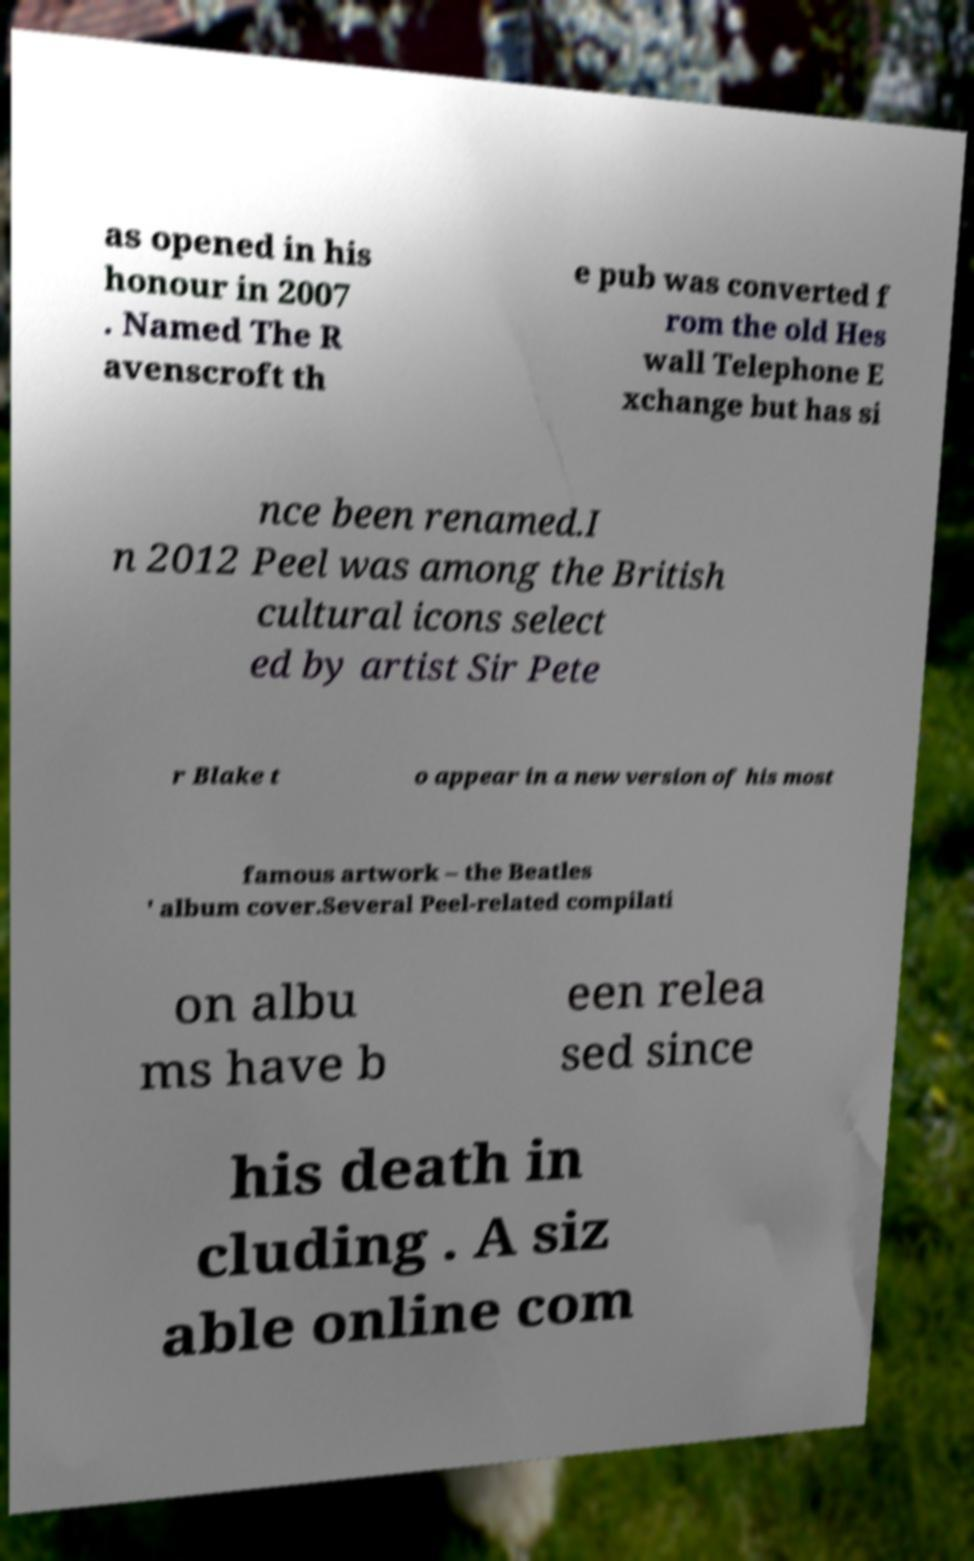I need the written content from this picture converted into text. Can you do that? as opened in his honour in 2007 . Named The R avenscroft th e pub was converted f rom the old Hes wall Telephone E xchange but has si nce been renamed.I n 2012 Peel was among the British cultural icons select ed by artist Sir Pete r Blake t o appear in a new version of his most famous artwork – the Beatles ' album cover.Several Peel-related compilati on albu ms have b een relea sed since his death in cluding . A siz able online com 